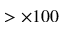Convert formula to latex. <formula><loc_0><loc_0><loc_500><loc_500>> \times 1 0 0</formula> 